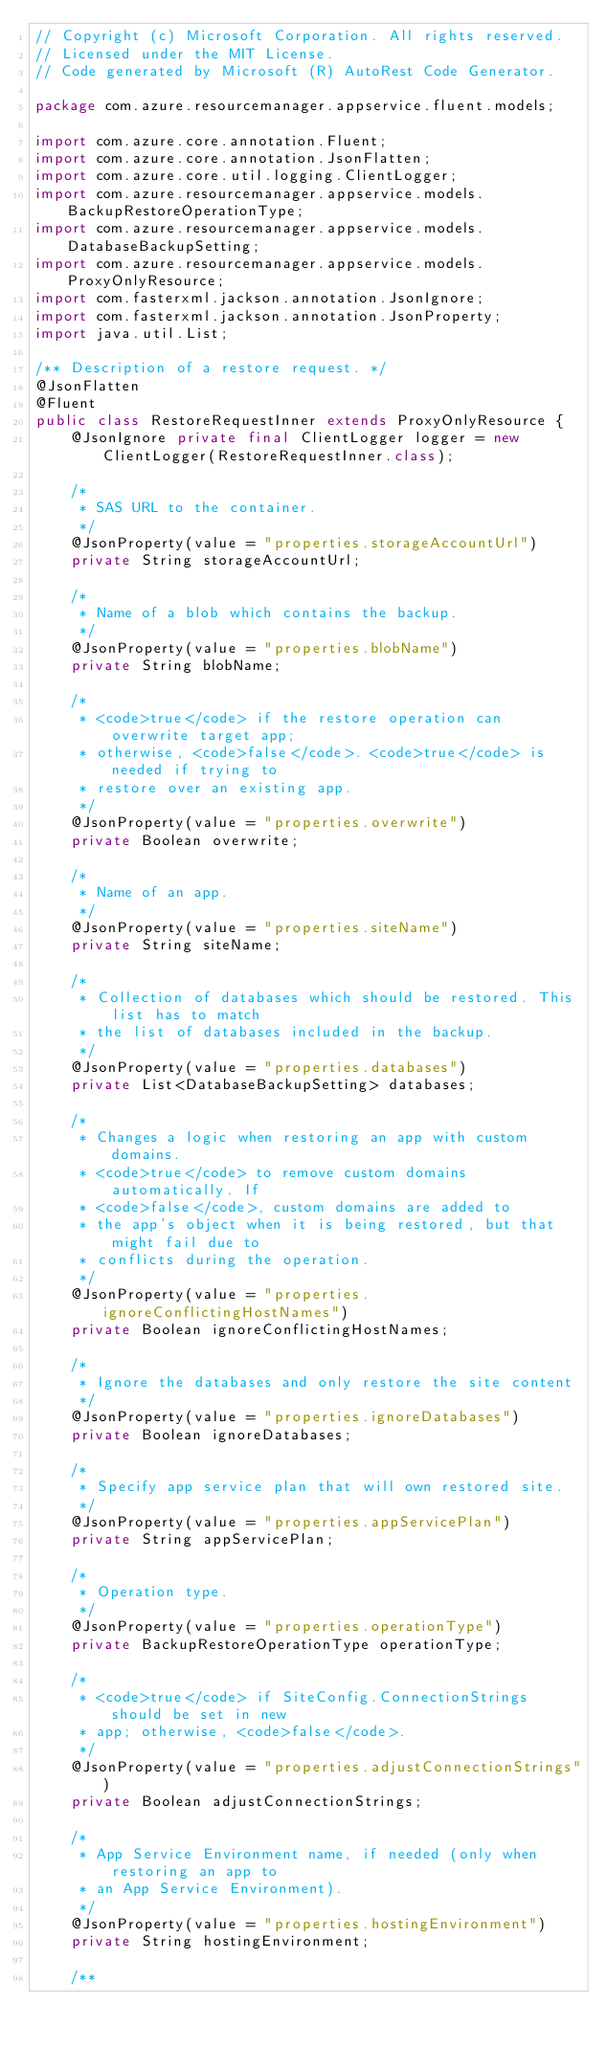<code> <loc_0><loc_0><loc_500><loc_500><_Java_>// Copyright (c) Microsoft Corporation. All rights reserved.
// Licensed under the MIT License.
// Code generated by Microsoft (R) AutoRest Code Generator.

package com.azure.resourcemanager.appservice.fluent.models;

import com.azure.core.annotation.Fluent;
import com.azure.core.annotation.JsonFlatten;
import com.azure.core.util.logging.ClientLogger;
import com.azure.resourcemanager.appservice.models.BackupRestoreOperationType;
import com.azure.resourcemanager.appservice.models.DatabaseBackupSetting;
import com.azure.resourcemanager.appservice.models.ProxyOnlyResource;
import com.fasterxml.jackson.annotation.JsonIgnore;
import com.fasterxml.jackson.annotation.JsonProperty;
import java.util.List;

/** Description of a restore request. */
@JsonFlatten
@Fluent
public class RestoreRequestInner extends ProxyOnlyResource {
    @JsonIgnore private final ClientLogger logger = new ClientLogger(RestoreRequestInner.class);

    /*
     * SAS URL to the container.
     */
    @JsonProperty(value = "properties.storageAccountUrl")
    private String storageAccountUrl;

    /*
     * Name of a blob which contains the backup.
     */
    @JsonProperty(value = "properties.blobName")
    private String blobName;

    /*
     * <code>true</code> if the restore operation can overwrite target app;
     * otherwise, <code>false</code>. <code>true</code> is needed if trying to
     * restore over an existing app.
     */
    @JsonProperty(value = "properties.overwrite")
    private Boolean overwrite;

    /*
     * Name of an app.
     */
    @JsonProperty(value = "properties.siteName")
    private String siteName;

    /*
     * Collection of databases which should be restored. This list has to match
     * the list of databases included in the backup.
     */
    @JsonProperty(value = "properties.databases")
    private List<DatabaseBackupSetting> databases;

    /*
     * Changes a logic when restoring an app with custom domains.
     * <code>true</code> to remove custom domains automatically. If
     * <code>false</code>, custom domains are added to
     * the app's object when it is being restored, but that might fail due to
     * conflicts during the operation.
     */
    @JsonProperty(value = "properties.ignoreConflictingHostNames")
    private Boolean ignoreConflictingHostNames;

    /*
     * Ignore the databases and only restore the site content
     */
    @JsonProperty(value = "properties.ignoreDatabases")
    private Boolean ignoreDatabases;

    /*
     * Specify app service plan that will own restored site.
     */
    @JsonProperty(value = "properties.appServicePlan")
    private String appServicePlan;

    /*
     * Operation type.
     */
    @JsonProperty(value = "properties.operationType")
    private BackupRestoreOperationType operationType;

    /*
     * <code>true</code> if SiteConfig.ConnectionStrings should be set in new
     * app; otherwise, <code>false</code>.
     */
    @JsonProperty(value = "properties.adjustConnectionStrings")
    private Boolean adjustConnectionStrings;

    /*
     * App Service Environment name, if needed (only when restoring an app to
     * an App Service Environment).
     */
    @JsonProperty(value = "properties.hostingEnvironment")
    private String hostingEnvironment;

    /**</code> 